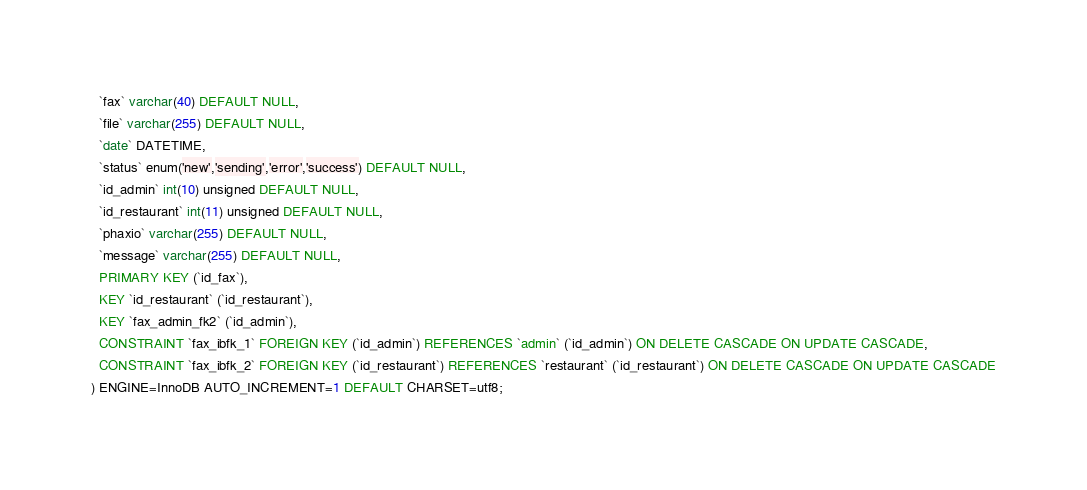<code> <loc_0><loc_0><loc_500><loc_500><_SQL_>  `fax` varchar(40) DEFAULT NULL,
  `file` varchar(255) DEFAULT NULL,
  `date` DATETIME,
  `status` enum('new','sending','error','success') DEFAULT NULL,
  `id_admin` int(10) unsigned DEFAULT NULL,
  `id_restaurant` int(11) unsigned DEFAULT NULL,
  `phaxio` varchar(255) DEFAULT NULL,
  `message` varchar(255) DEFAULT NULL,
  PRIMARY KEY (`id_fax`),
  KEY `id_restaurant` (`id_restaurant`),
  KEY `fax_admin_fk2` (`id_admin`),
  CONSTRAINT `fax_ibfk_1` FOREIGN KEY (`id_admin`) REFERENCES `admin` (`id_admin`) ON DELETE CASCADE ON UPDATE CASCADE,
  CONSTRAINT `fax_ibfk_2` FOREIGN KEY (`id_restaurant`) REFERENCES `restaurant` (`id_restaurant`) ON DELETE CASCADE ON UPDATE CASCADE
) ENGINE=InnoDB AUTO_INCREMENT=1 DEFAULT CHARSET=utf8;</code> 